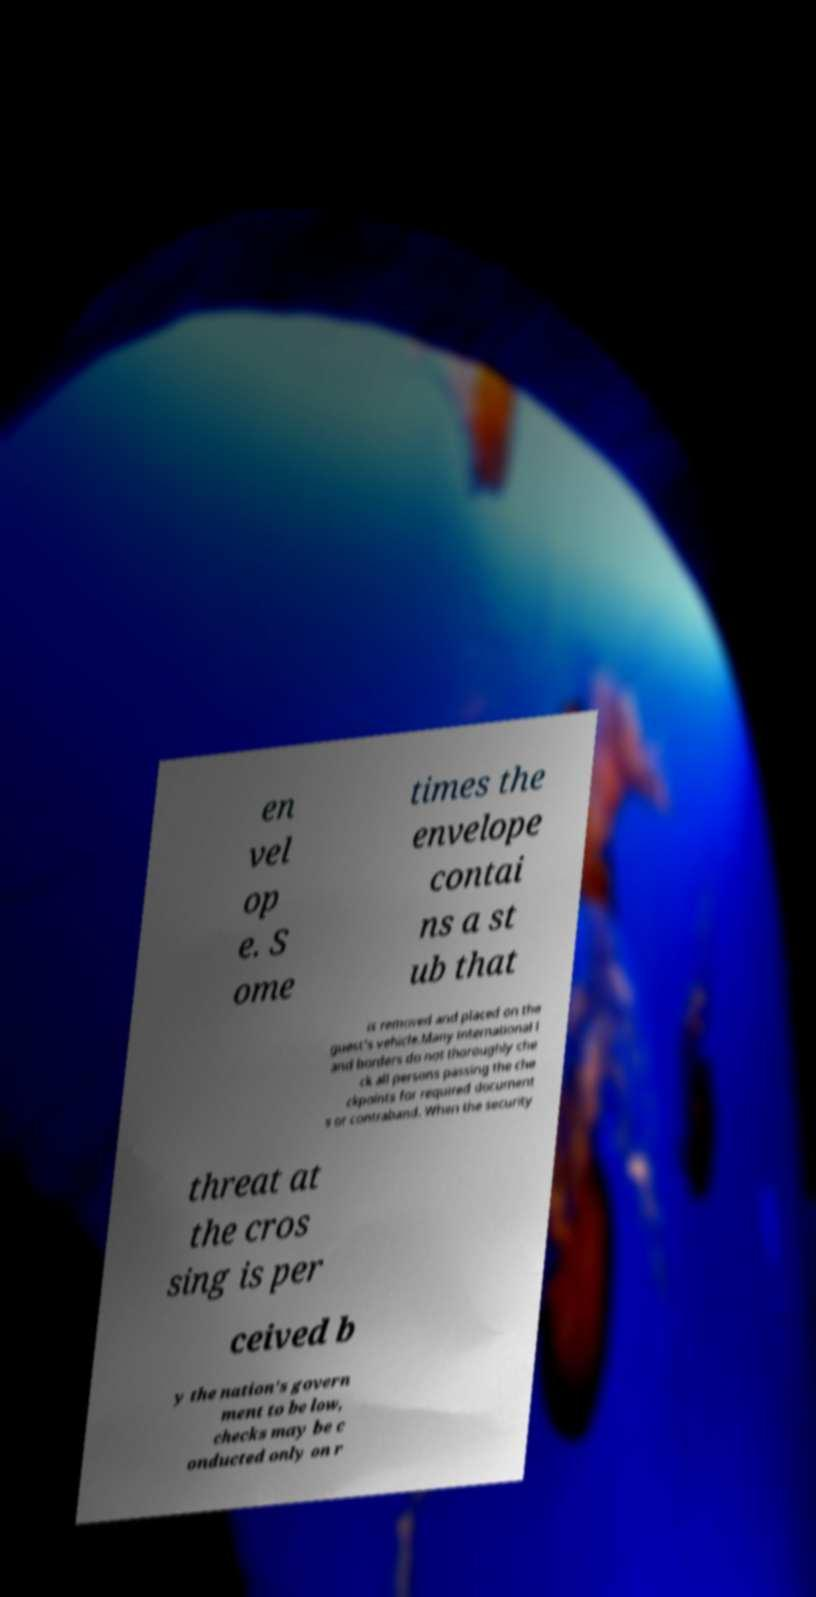For documentation purposes, I need the text within this image transcribed. Could you provide that? en vel op e. S ome times the envelope contai ns a st ub that is removed and placed on the guest's vehicle.Many international l and borders do not thoroughly che ck all persons passing the che ckpoints for required document s or contraband. When the security threat at the cros sing is per ceived b y the nation's govern ment to be low, checks may be c onducted only on r 